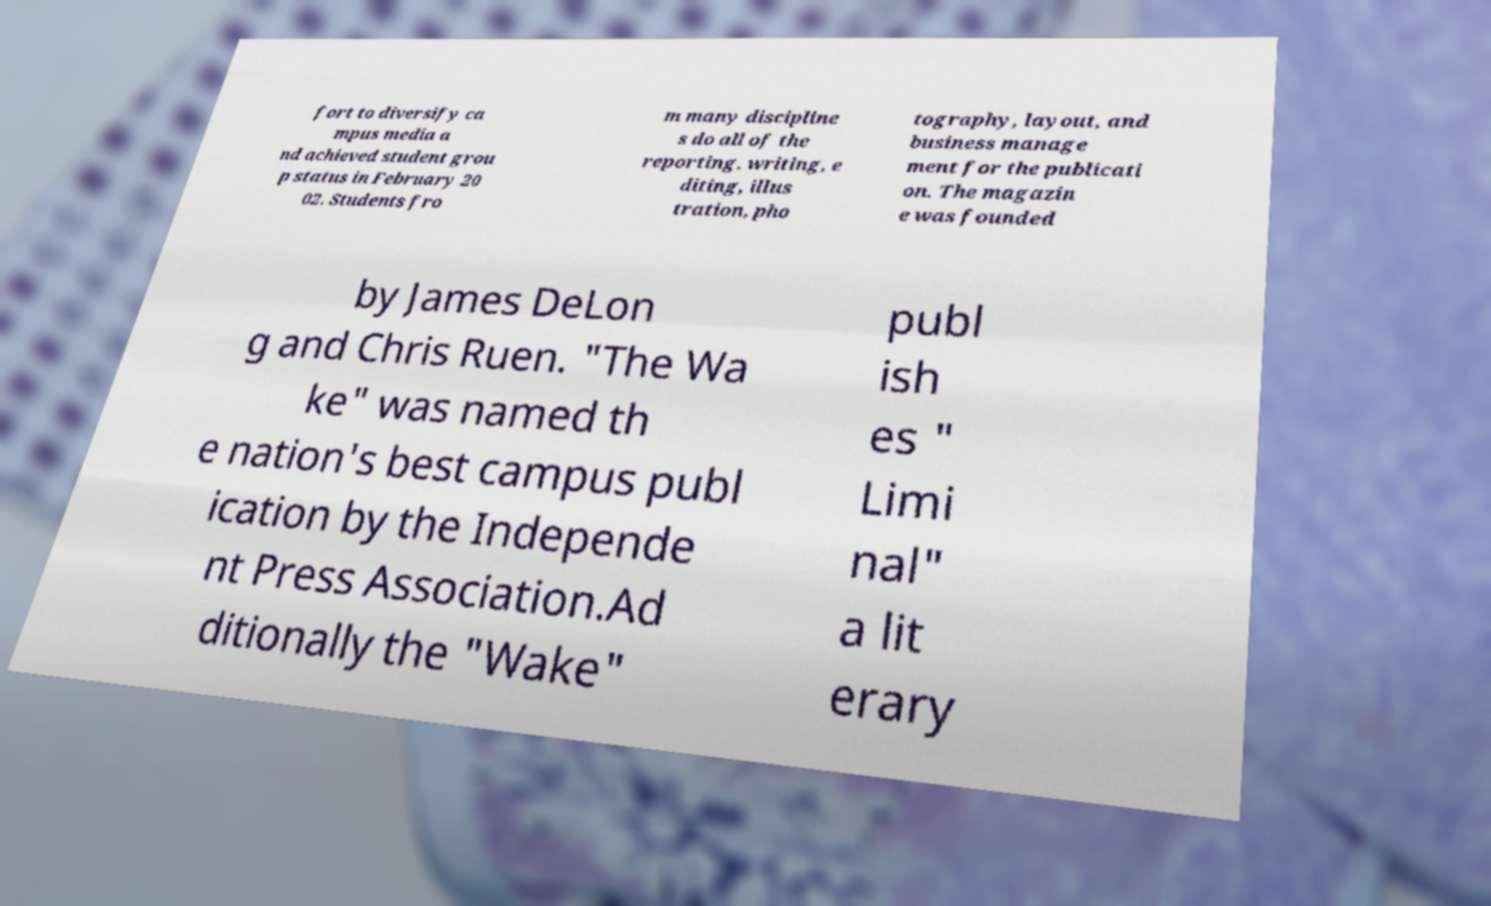I need the written content from this picture converted into text. Can you do that? fort to diversify ca mpus media a nd achieved student grou p status in February 20 02. Students fro m many discipline s do all of the reporting, writing, e diting, illus tration, pho tography, layout, and business manage ment for the publicati on. The magazin e was founded by James DeLon g and Chris Ruen. "The Wa ke" was named th e nation's best campus publ ication by the Independe nt Press Association.Ad ditionally the "Wake" publ ish es " Limi nal" a lit erary 